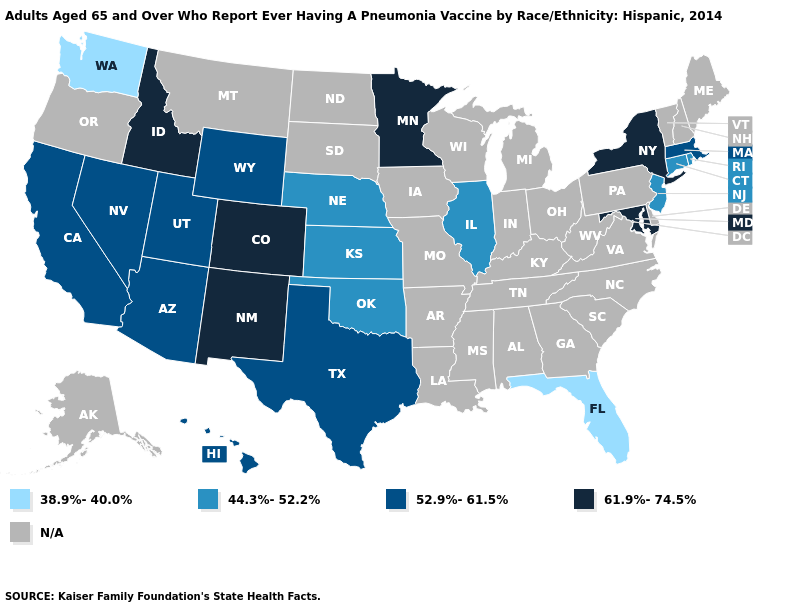What is the lowest value in the West?
Give a very brief answer. 38.9%-40.0%. Among the states that border Arizona , which have the highest value?
Write a very short answer. Colorado, New Mexico. Does New Jersey have the lowest value in the USA?
Be succinct. No. What is the value of New Jersey?
Be succinct. 44.3%-52.2%. What is the highest value in the Northeast ?
Answer briefly. 61.9%-74.5%. Which states hav the highest value in the South?
Concise answer only. Maryland. What is the value of Missouri?
Concise answer only. N/A. What is the highest value in states that border Iowa?
Concise answer only. 61.9%-74.5%. Does the map have missing data?
Quick response, please. Yes. What is the value of Idaho?
Write a very short answer. 61.9%-74.5%. What is the value of California?
Concise answer only. 52.9%-61.5%. Name the states that have a value in the range 61.9%-74.5%?
Give a very brief answer. Colorado, Idaho, Maryland, Minnesota, New Mexico, New York. Name the states that have a value in the range 61.9%-74.5%?
Give a very brief answer. Colorado, Idaho, Maryland, Minnesota, New Mexico, New York. Name the states that have a value in the range 38.9%-40.0%?
Concise answer only. Florida, Washington. Name the states that have a value in the range 44.3%-52.2%?
Be succinct. Connecticut, Illinois, Kansas, Nebraska, New Jersey, Oklahoma, Rhode Island. 